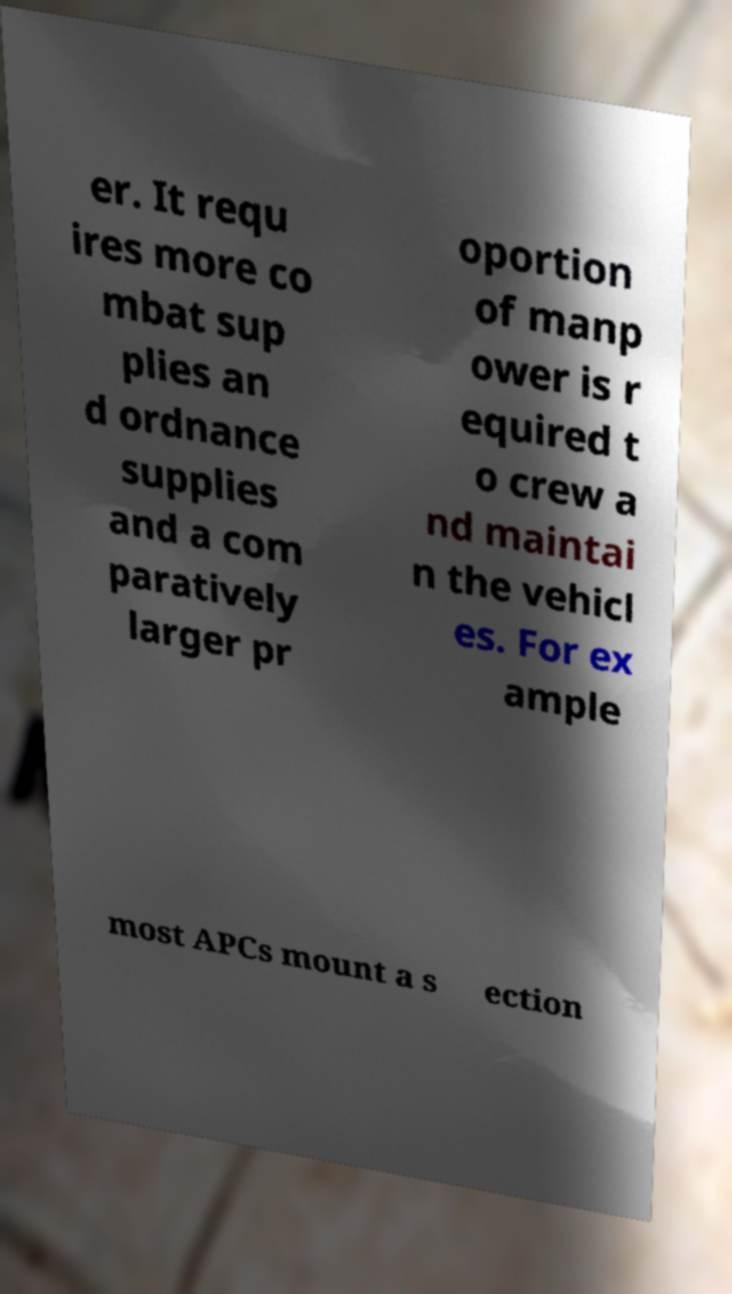For documentation purposes, I need the text within this image transcribed. Could you provide that? er. It requ ires more co mbat sup plies an d ordnance supplies and a com paratively larger pr oportion of manp ower is r equired t o crew a nd maintai n the vehicl es. For ex ample most APCs mount a s ection 